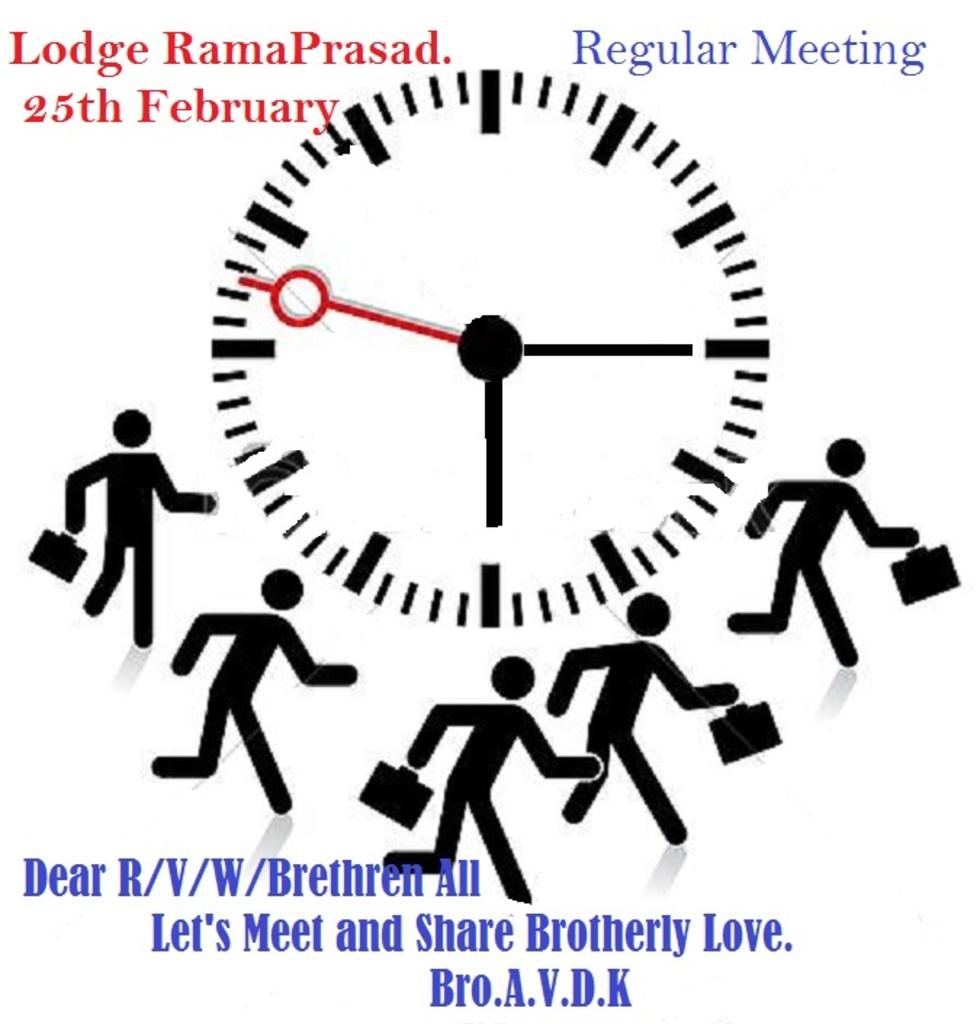<image>
Summarize the visual content of the image. a clock and many figures running to a regular meeting 